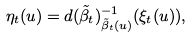<formula> <loc_0><loc_0><loc_500><loc_500>\eta _ { t } ( u ) = d ( \tilde { \beta } _ { t } ) ^ { - 1 } _ { \tilde { \beta } _ { t } ( u ) } ( \xi _ { t } ( u ) ) ,</formula> 